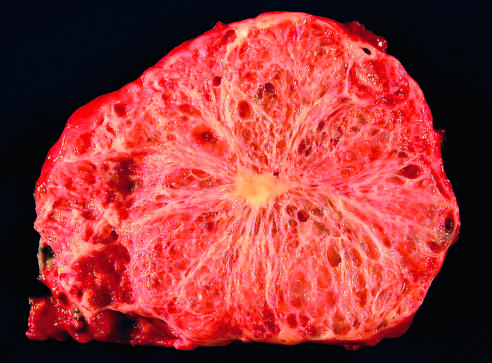does only a thin rim of normal pancreatic parenchyma remain?
Answer the question using a single word or phrase. Yes 